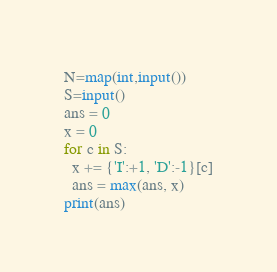<code> <loc_0><loc_0><loc_500><loc_500><_Python_>N=map(int,input())
S=input()
ans = 0
x = 0
for c in S:
  x += {'I':+1, 'D':-1}[c]
  ans = max(ans, x)
print(ans)</code> 